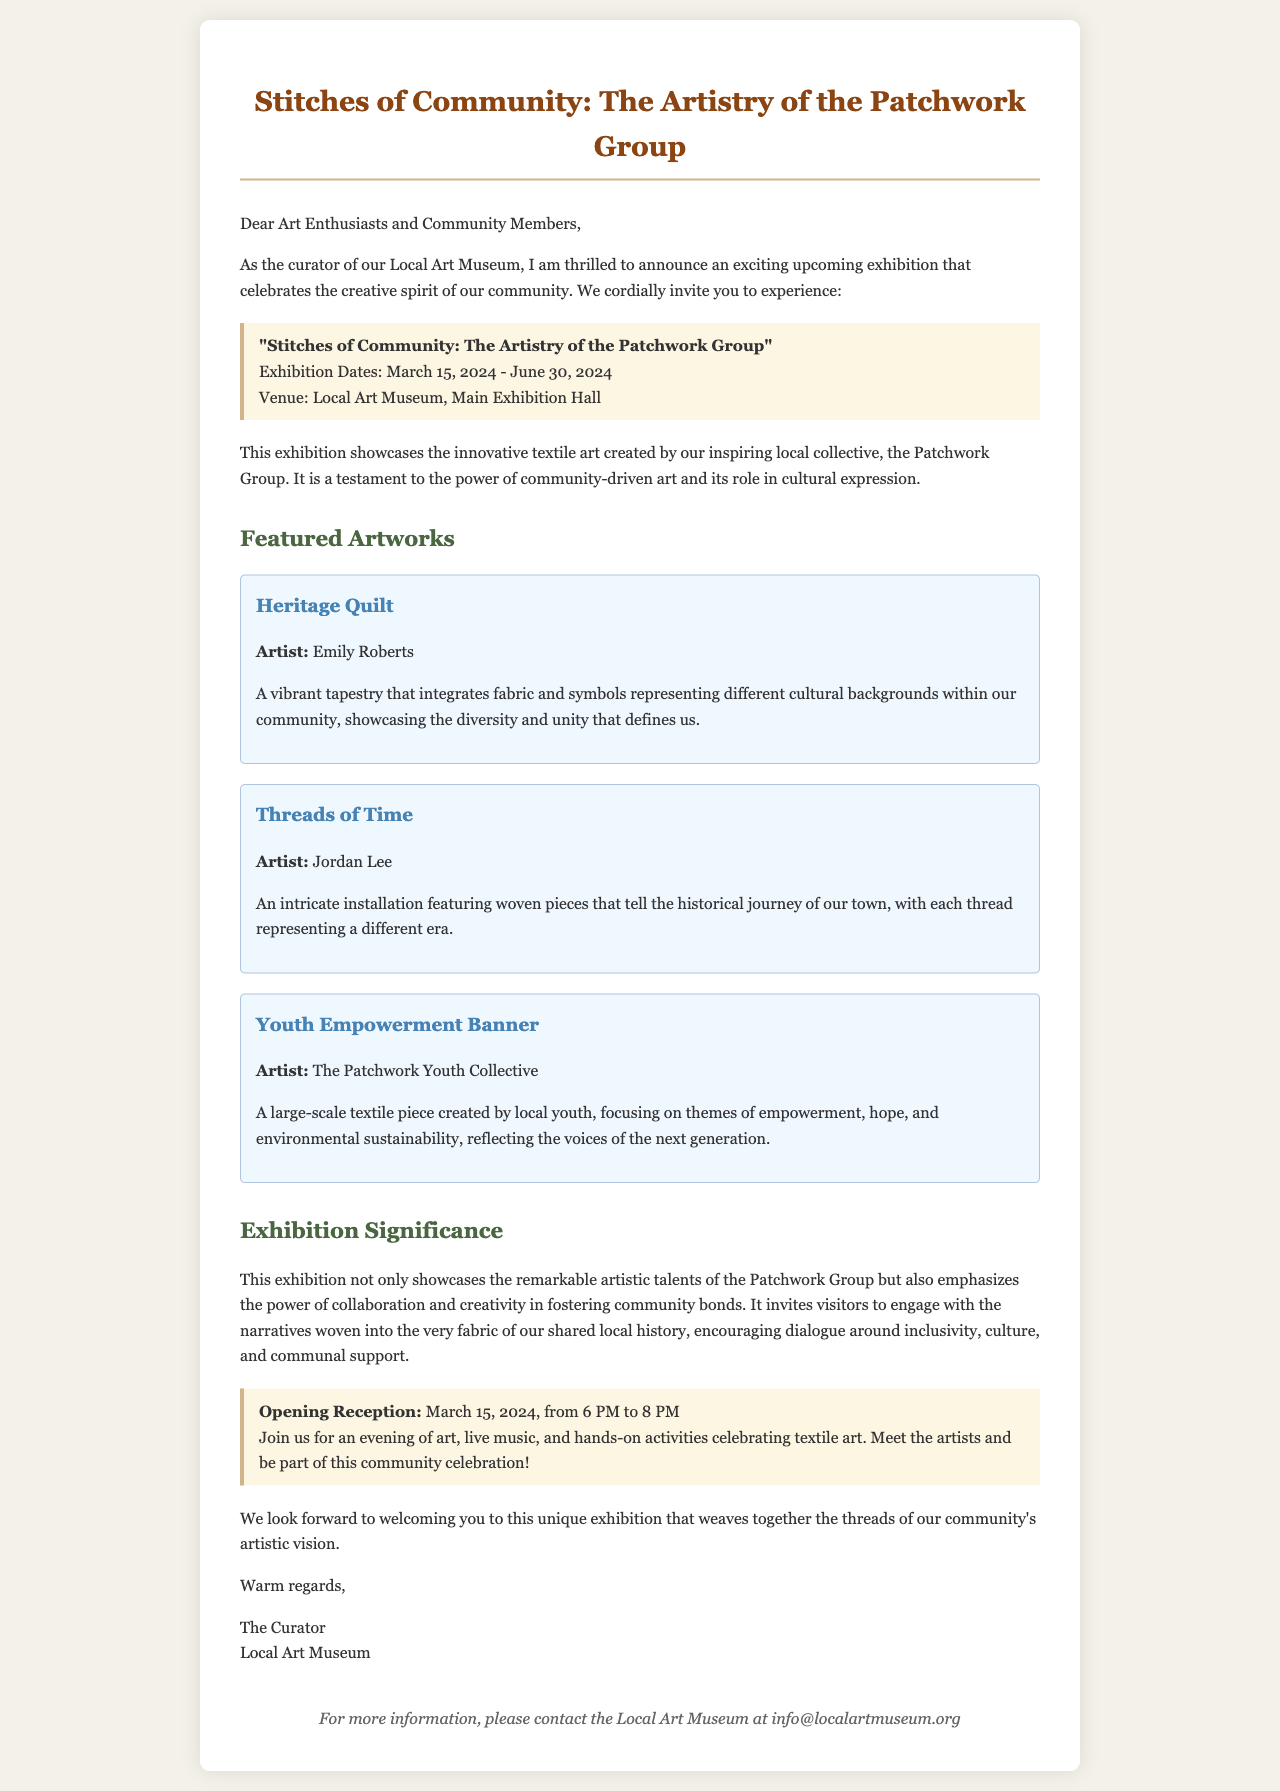What is the title of the exhibition? The title of the exhibition is stated clearly in the document.
Answer: Stitches of Community: The Artistry of the Patchwork Group When does the exhibition open? The opening date is provided in the highlight section of the document.
Answer: March 15, 2024 Who is the artist of the Heritage Quilt? The artist's name for the Heritage Quilt is mentioned in the description of the artwork.
Answer: Emily Roberts What themes does the Youth Empowerment Banner focus on? The themes are outlined in the description of the specific artwork.
Answer: Empowerment, hope, and environmental sustainability What is the purpose of the exhibition according to the curator? The purpose is discussed in the significance section of the document.
Answer: To showcase artistic talents and foster community bonds What date will the opening reception occur? The opening reception date is highlighted in the document.
Answer: March 15, 2024 Where is the exhibition being held? The venue is specified at the beginning of the announcement.
Answer: Local Art Museum, Main Exhibition Hall What will attendees experience at the opening reception? The experiences expected at the opening reception are detailed in the highlight section.
Answer: Art, live music, and hands-on activities 